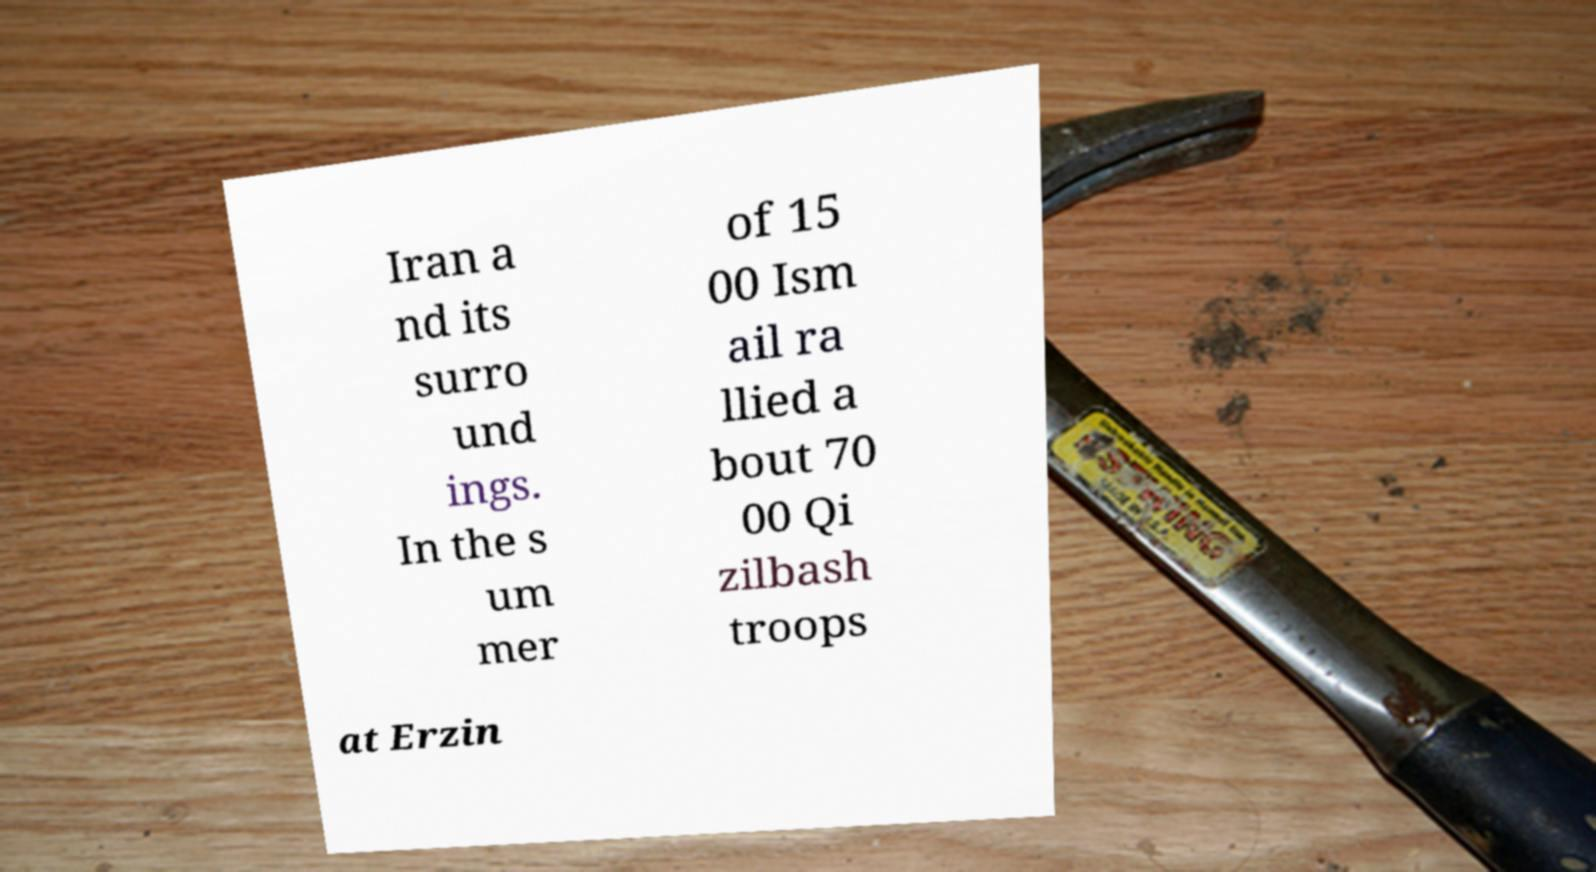Could you assist in decoding the text presented in this image and type it out clearly? Iran a nd its surro und ings. In the s um mer of 15 00 Ism ail ra llied a bout 70 00 Qi zilbash troops at Erzin 